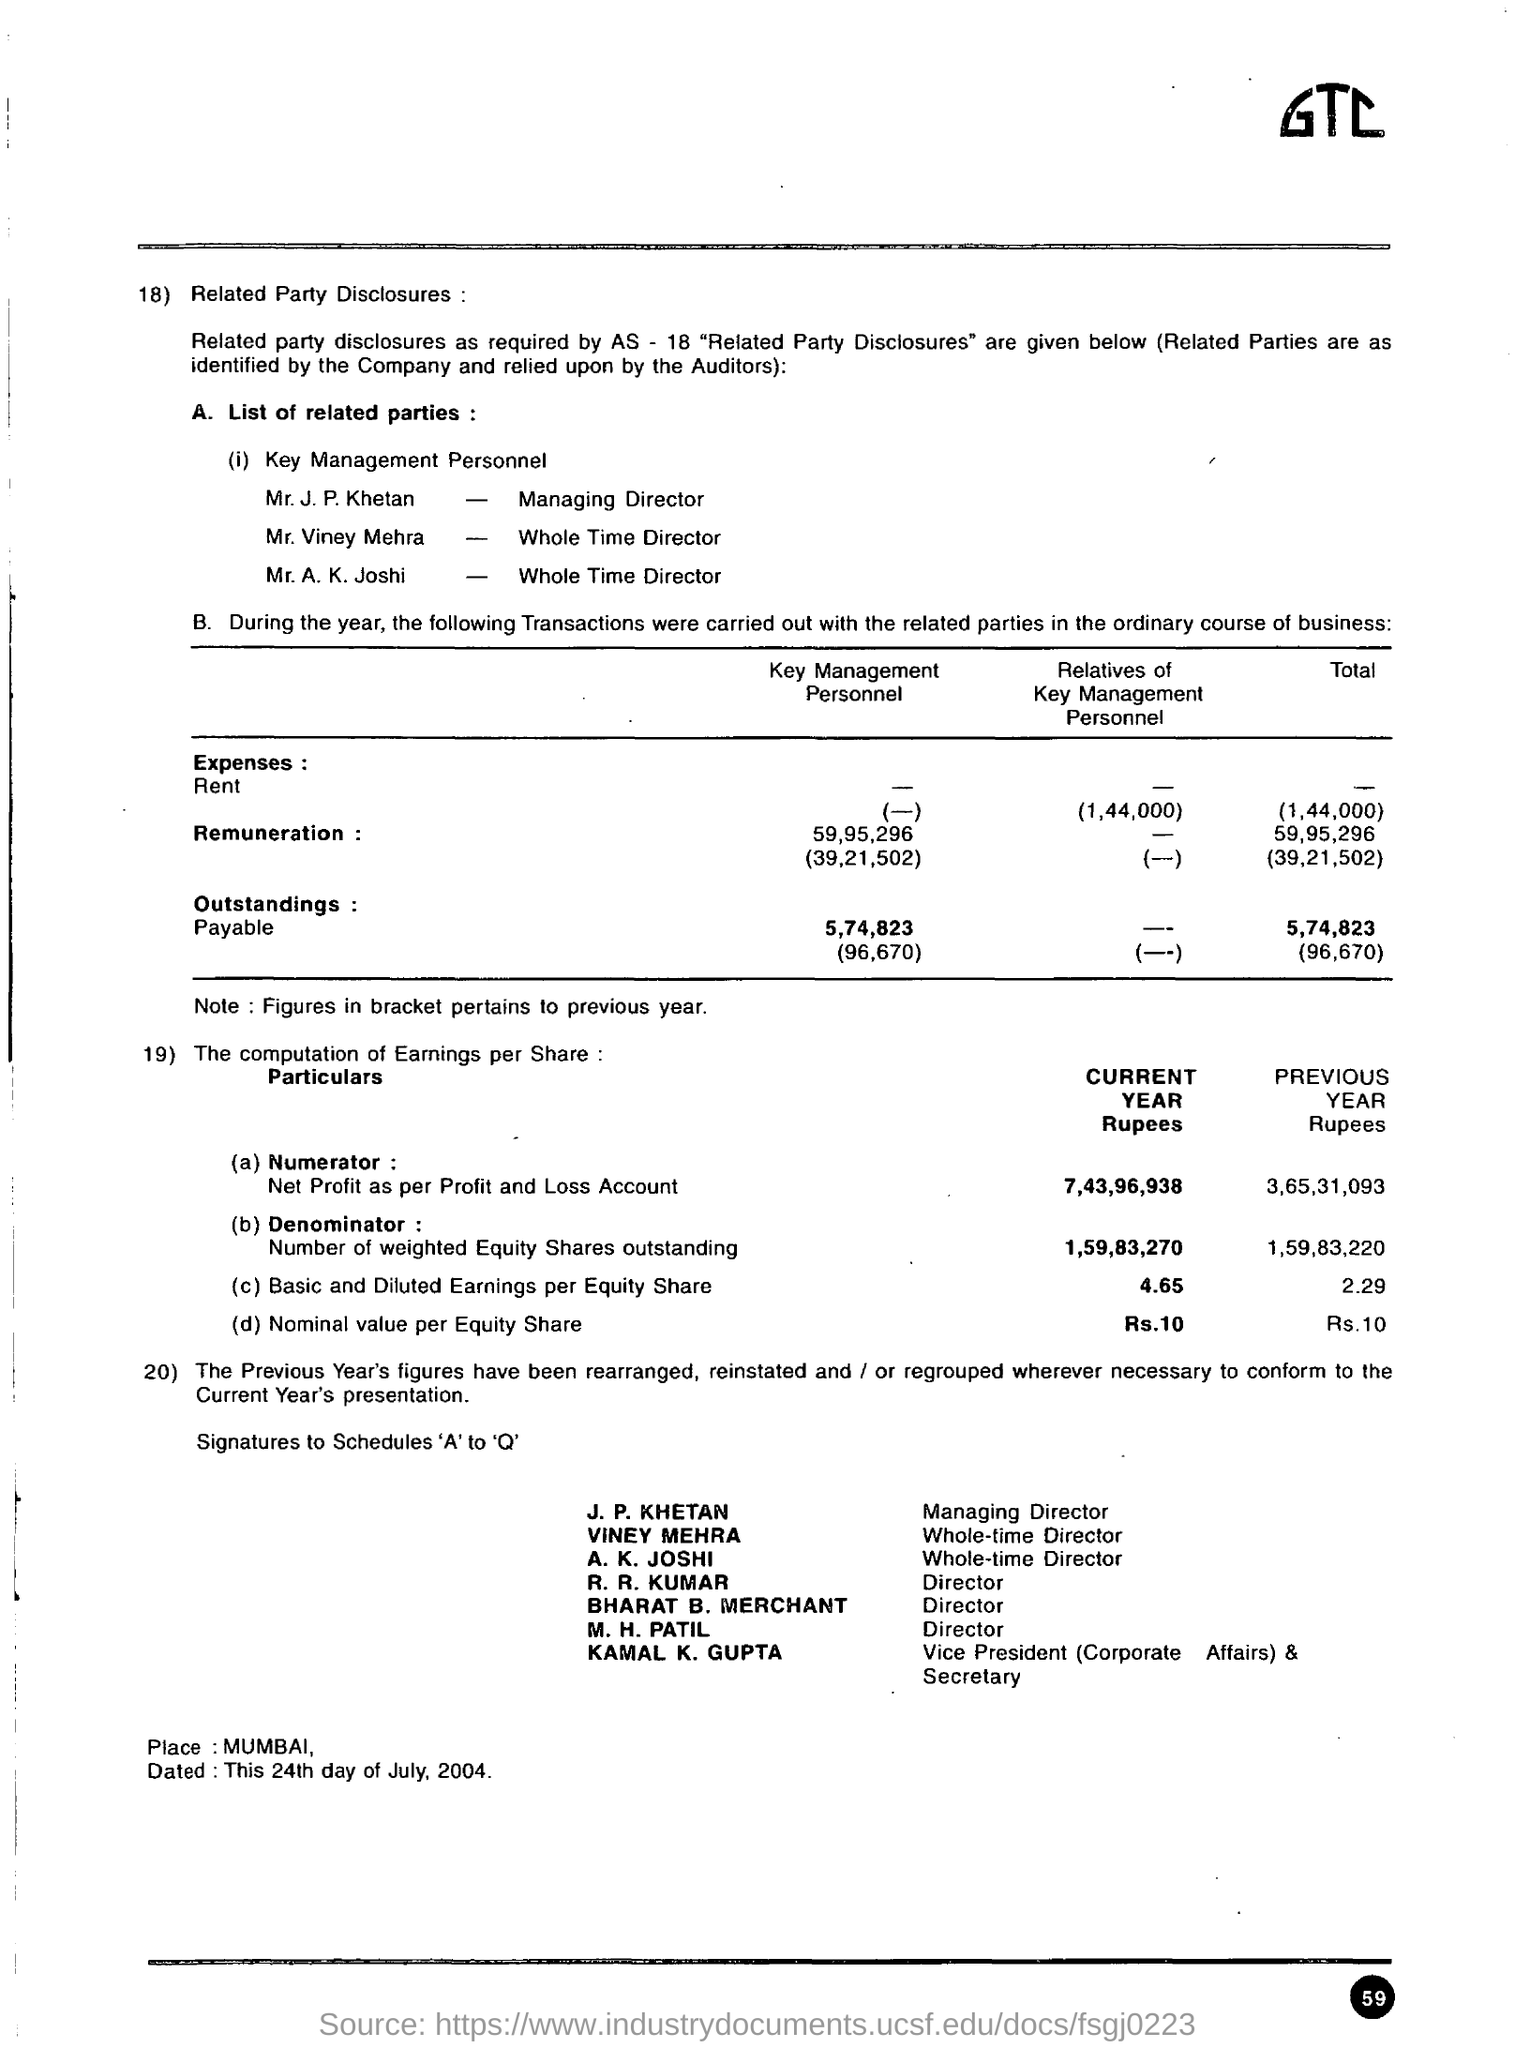Point out several critical features in this image. What is the nominal value per equity share in the current year? The nominal value per equity share is 10. The place mentioned in the given disclosure is Mumbai. The basic and diluted earnings per equity share for the current year are 4.65. The previous year's basic and diluted earnings per equity share were 2.29. 